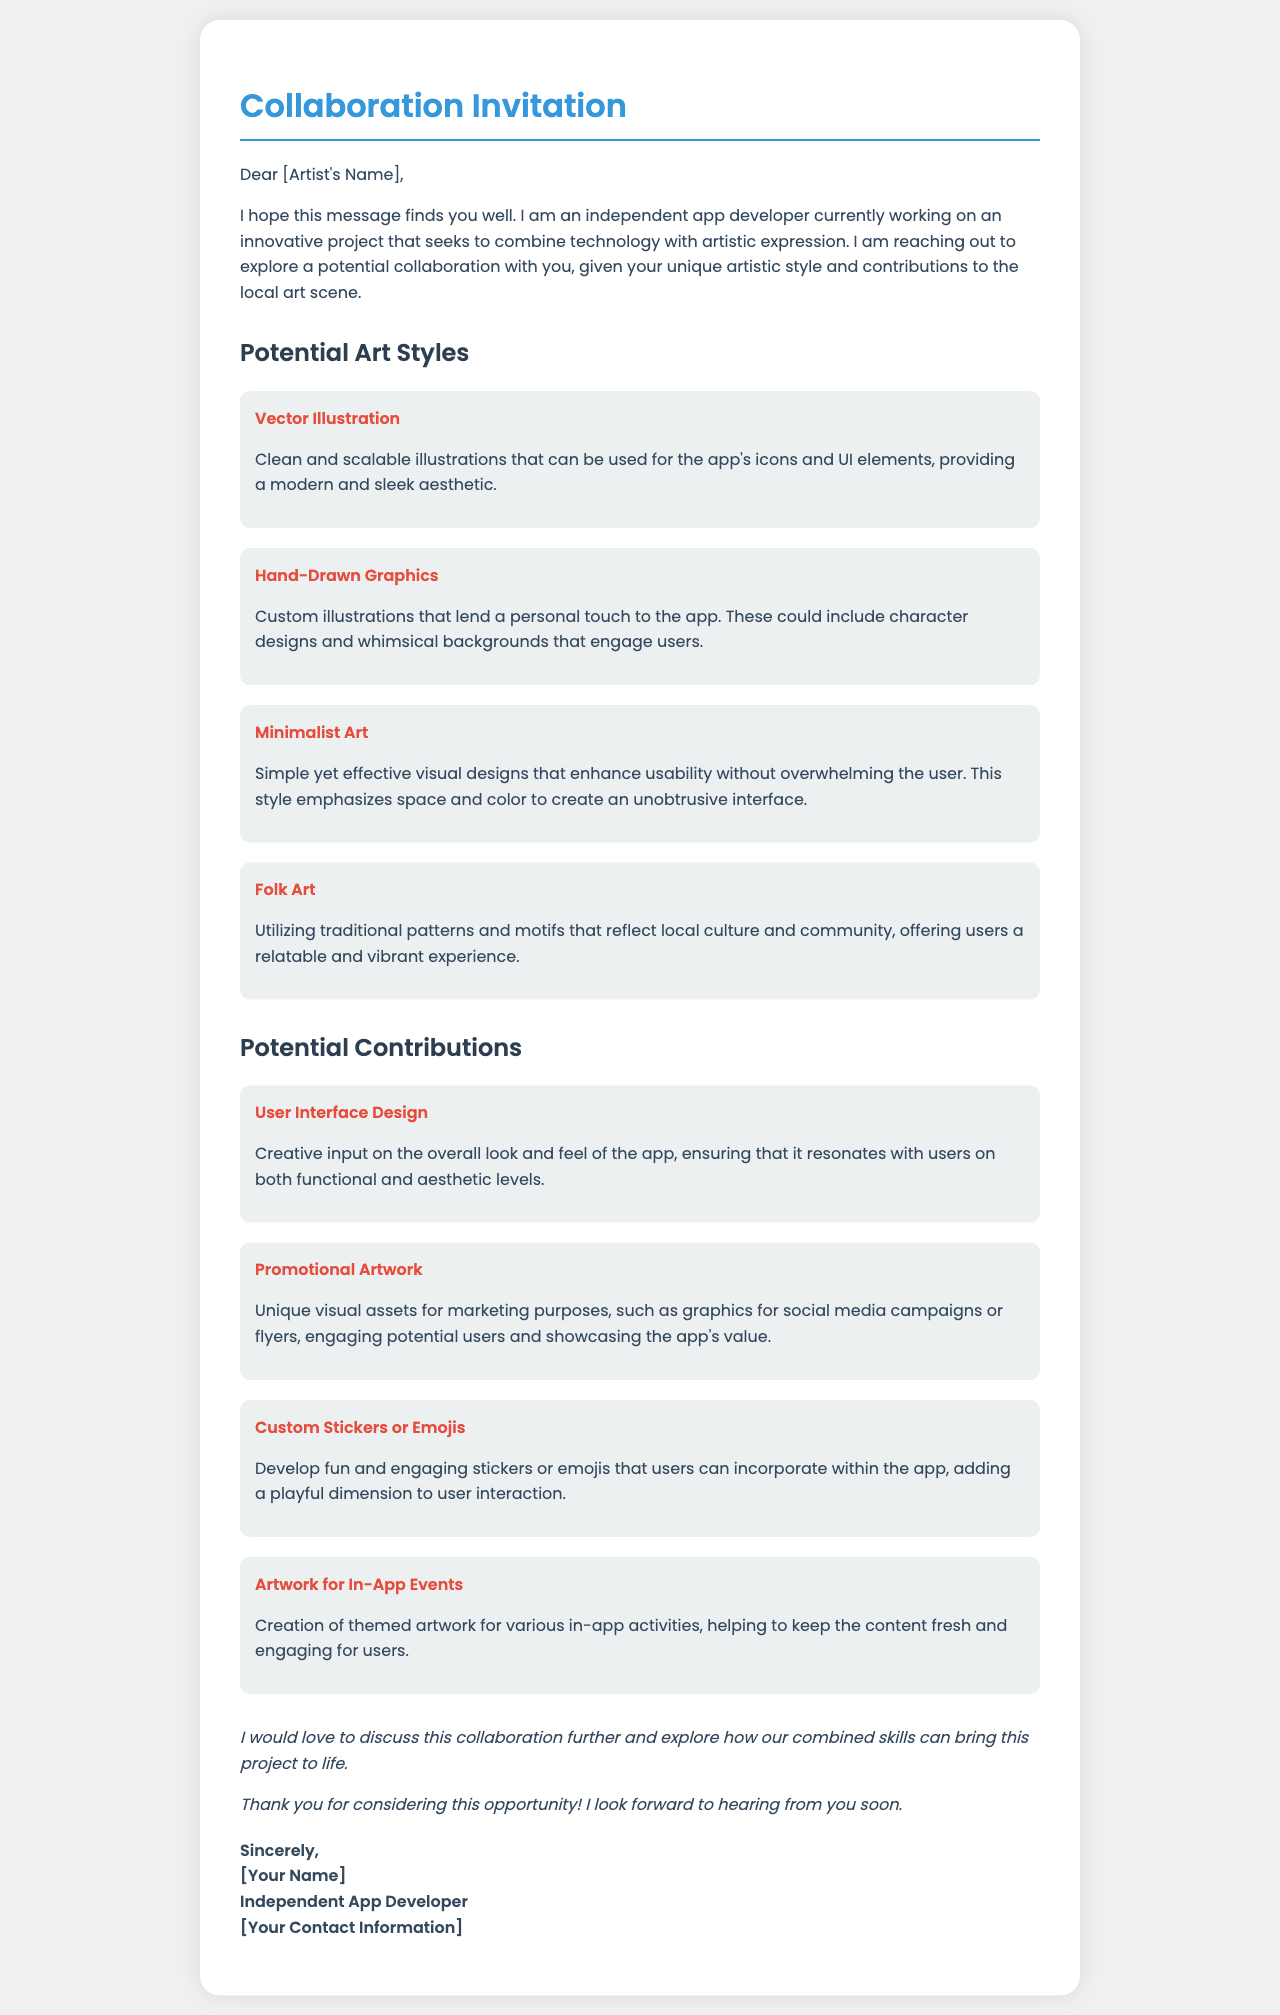What is the title of the document? The title of the document is indicated in the <title> tag of the HTML, which is "Collaboration Invitation."
Answer: Collaboration Invitation Who is the intended recipient of the letter? The letter starts with "Dear [Artist's Name]," suggesting the recipient is an artist.
Answer: [Artist's Name] What is one potential art style mentioned in the document? The document lists four art styles, one of which is "Vector Illustration."
Answer: Vector Illustration What contribution involves custom stickers or emojis? The document lists "Custom Stickers or Emojis" as one of the potential contributions.
Answer: Custom Stickers or Emojis How many potential art styles are listed in the document? The document enumerates four different potential art styles.
Answer: Four Which color is used for headings in the document? The color for headings is specified as "color: #3498db" in the CSS style section.
Answer: #3498db What is one of the closing remarks in the letter? The letter contains a closing remark that states, "I would love to discuss this collaboration further."
Answer: I would love to discuss this collaboration further What type of document is this? This is an invitation letter aimed at proposing a collaboration with an artist for an app project.
Answer: Invitation letter 